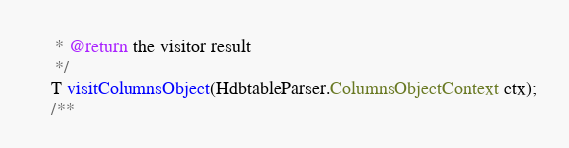<code> <loc_0><loc_0><loc_500><loc_500><_Java_>	 * @return the visitor result
	 */
	T visitColumnsObject(HdbtableParser.ColumnsObjectContext ctx);
	/**</code> 